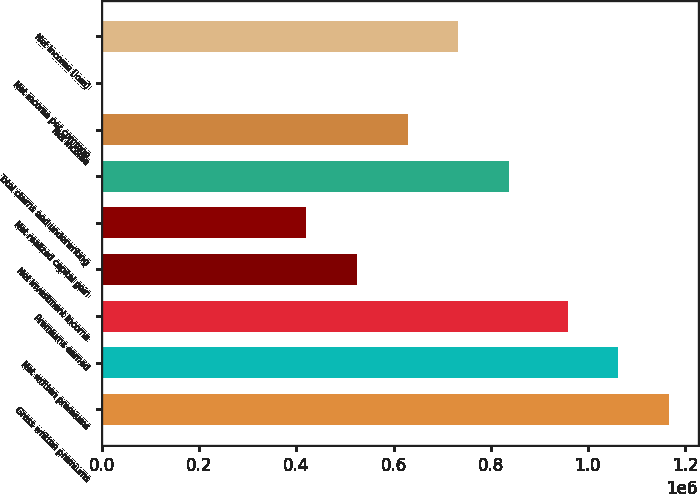<chart> <loc_0><loc_0><loc_500><loc_500><bar_chart><fcel>Gross written premiums<fcel>Net written premiums<fcel>Premiums earned<fcel>Net investment income<fcel>Net realized capital gain<fcel>Total claims and underwriting<fcel>Net income<fcel>Net income per common<fcel>Net income (loss)<nl><fcel>1.16797e+06<fcel>1.06316e+06<fcel>958343<fcel>524082<fcel>419267<fcel>838530<fcel>628898<fcel>3.76<fcel>733714<nl></chart> 